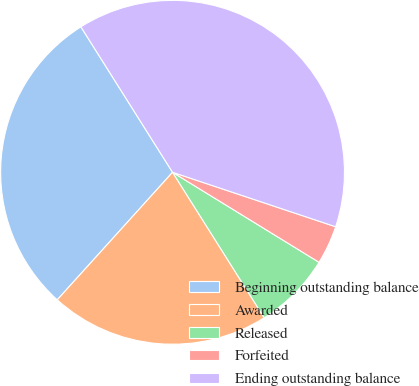Convert chart. <chart><loc_0><loc_0><loc_500><loc_500><pie_chart><fcel>Beginning outstanding balance<fcel>Awarded<fcel>Released<fcel>Forfeited<fcel>Ending outstanding balance<nl><fcel>29.35%<fcel>20.65%<fcel>7.28%<fcel>3.64%<fcel>39.08%<nl></chart> 